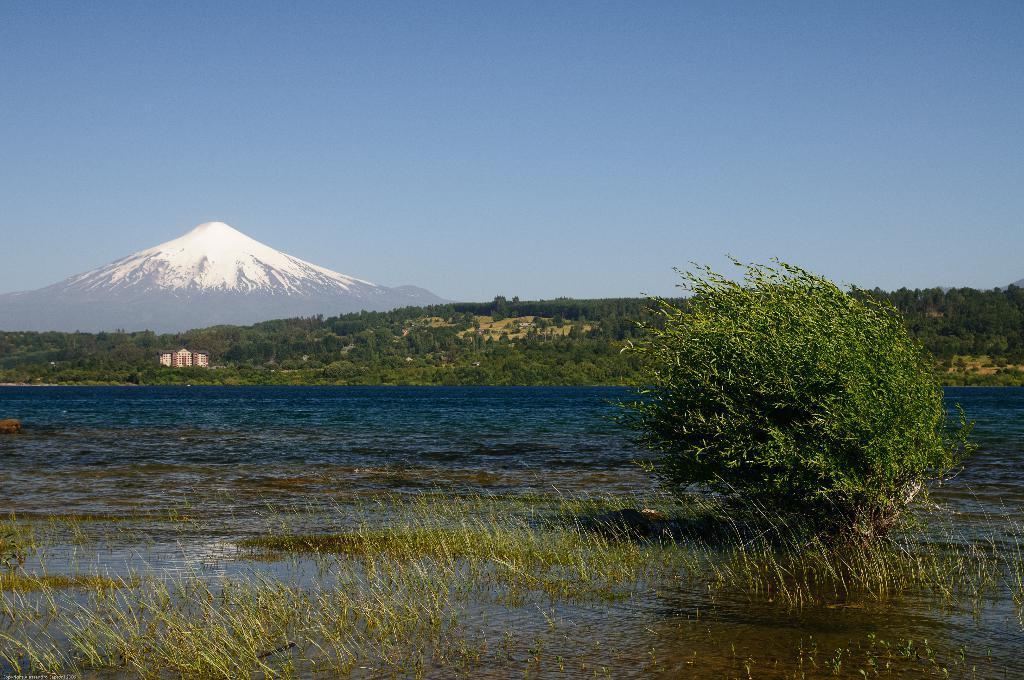Describe this image in one or two sentences. In this picture, we can see water, grass, plants, ground, trees, buildings, mountain, and the sky. 